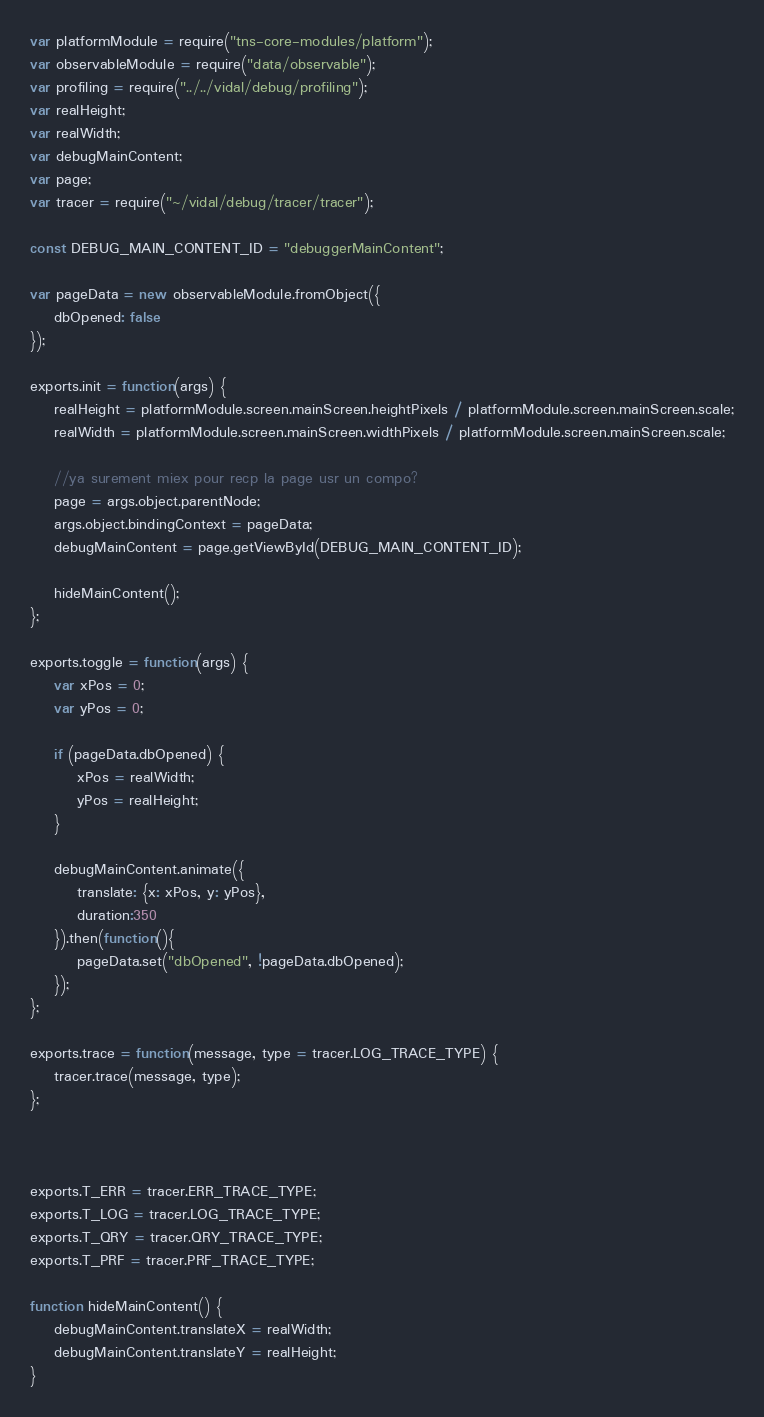<code> <loc_0><loc_0><loc_500><loc_500><_JavaScript_>var platformModule = require("tns-core-modules/platform");
var observableModule = require("data/observable");
var profiling = require("../../vidal/debug/profiling");
var realHeight;
var realWidth;
var debugMainContent;
var page;
var tracer = require("~/vidal/debug/tracer/tracer");

const DEBUG_MAIN_CONTENT_ID = "debuggerMainContent";

var pageData = new observableModule.fromObject({
    dbOpened: false
});

exports.init = function(args) {
    realHeight = platformModule.screen.mainScreen.heightPixels / platformModule.screen.mainScreen.scale;
    realWidth = platformModule.screen.mainScreen.widthPixels / platformModule.screen.mainScreen.scale;

    //ya surement miex pour recp la page usr un compo?
    page = args.object.parentNode;
    args.object.bindingContext = pageData;
    debugMainContent = page.getViewById(DEBUG_MAIN_CONTENT_ID);

    hideMainContent();
};

exports.toggle = function(args) {
    var xPos = 0;
    var yPos = 0;

    if (pageData.dbOpened) {
        xPos = realWidth;
        yPos = realHeight;
    }

    debugMainContent.animate({
        translate: {x: xPos, y: yPos},
        duration:350
    }).then(function(){
        pageData.set("dbOpened", !pageData.dbOpened);
    });
};

exports.trace = function(message, type = tracer.LOG_TRACE_TYPE) {
    tracer.trace(message, type);
};



exports.T_ERR = tracer.ERR_TRACE_TYPE;
exports.T_LOG = tracer.LOG_TRACE_TYPE;
exports.T_QRY = tracer.QRY_TRACE_TYPE;
exports.T_PRF = tracer.PRF_TRACE_TYPE;

function hideMainContent() {
    debugMainContent.translateX = realWidth;
    debugMainContent.translateY = realHeight;
}
</code> 